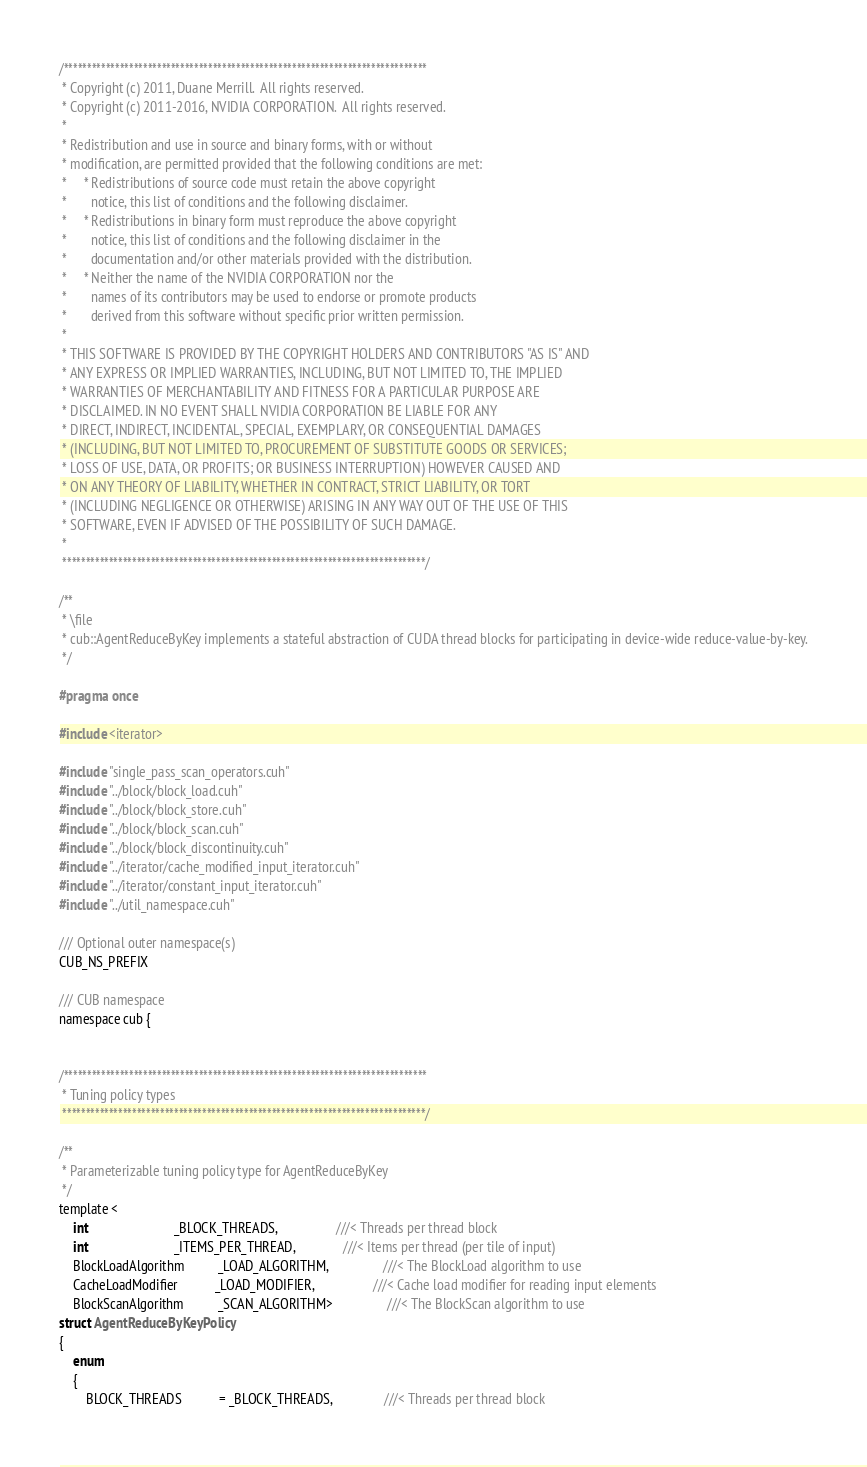Convert code to text. <code><loc_0><loc_0><loc_500><loc_500><_Cuda_>/******************************************************************************
 * Copyright (c) 2011, Duane Merrill.  All rights reserved.
 * Copyright (c) 2011-2016, NVIDIA CORPORATION.  All rights reserved.
 *
 * Redistribution and use in source and binary forms, with or without
 * modification, are permitted provided that the following conditions are met:
 *     * Redistributions of source code must retain the above copyright
 *       notice, this list of conditions and the following disclaimer.
 *     * Redistributions in binary form must reproduce the above copyright
 *       notice, this list of conditions and the following disclaimer in the
 *       documentation and/or other materials provided with the distribution.
 *     * Neither the name of the NVIDIA CORPORATION nor the
 *       names of its contributors may be used to endorse or promote products
 *       derived from this software without specific prior written permission.
 *
 * THIS SOFTWARE IS PROVIDED BY THE COPYRIGHT HOLDERS AND CONTRIBUTORS "AS IS" AND
 * ANY EXPRESS OR IMPLIED WARRANTIES, INCLUDING, BUT NOT LIMITED TO, THE IMPLIED
 * WARRANTIES OF MERCHANTABILITY AND FITNESS FOR A PARTICULAR PURPOSE ARE
 * DISCLAIMED. IN NO EVENT SHALL NVIDIA CORPORATION BE LIABLE FOR ANY
 * DIRECT, INDIRECT, INCIDENTAL, SPECIAL, EXEMPLARY, OR CONSEQUENTIAL DAMAGES
 * (INCLUDING, BUT NOT LIMITED TO, PROCUREMENT OF SUBSTITUTE GOODS OR SERVICES;
 * LOSS OF USE, DATA, OR PROFITS; OR BUSINESS INTERRUPTION) HOWEVER CAUSED AND
 * ON ANY THEORY OF LIABILITY, WHETHER IN CONTRACT, STRICT LIABILITY, OR TORT
 * (INCLUDING NEGLIGENCE OR OTHERWISE) ARISING IN ANY WAY OUT OF THE USE OF THIS
 * SOFTWARE, EVEN IF ADVISED OF THE POSSIBILITY OF SUCH DAMAGE.
 *
 ******************************************************************************/

/**
 * \file
 * cub::AgentReduceByKey implements a stateful abstraction of CUDA thread blocks for participating in device-wide reduce-value-by-key.
 */

#pragma once

#include <iterator>

#include "single_pass_scan_operators.cuh"
#include "../block/block_load.cuh"
#include "../block/block_store.cuh"
#include "../block/block_scan.cuh"
#include "../block/block_discontinuity.cuh"
#include "../iterator/cache_modified_input_iterator.cuh"
#include "../iterator/constant_input_iterator.cuh"
#include "../util_namespace.cuh"

/// Optional outer namespace(s)
CUB_NS_PREFIX

/// CUB namespace
namespace cub {


/******************************************************************************
 * Tuning policy types
 ******************************************************************************/

/**
 * Parameterizable tuning policy type for AgentReduceByKey
 */
template <
    int                         _BLOCK_THREADS,                 ///< Threads per thread block
    int                         _ITEMS_PER_THREAD,              ///< Items per thread (per tile of input)
    BlockLoadAlgorithm          _LOAD_ALGORITHM,                ///< The BlockLoad algorithm to use
    CacheLoadModifier           _LOAD_MODIFIER,                 ///< Cache load modifier for reading input elements
    BlockScanAlgorithm          _SCAN_ALGORITHM>                ///< The BlockScan algorithm to use
struct AgentReduceByKeyPolicy
{
    enum
    {
        BLOCK_THREADS           = _BLOCK_THREADS,               ///< Threads per thread block</code> 